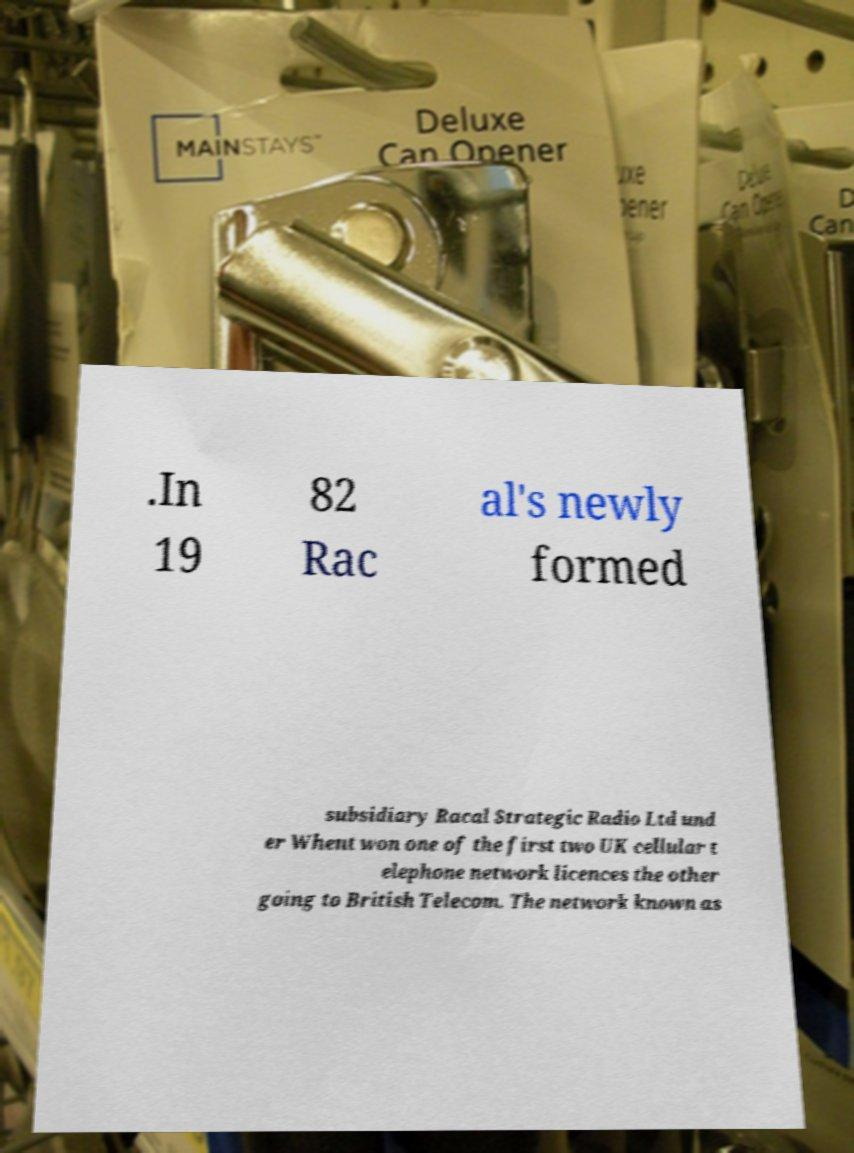Please read and relay the text visible in this image. What does it say? .In 19 82 Rac al's newly formed subsidiary Racal Strategic Radio Ltd und er Whent won one of the first two UK cellular t elephone network licences the other going to British Telecom. The network known as 